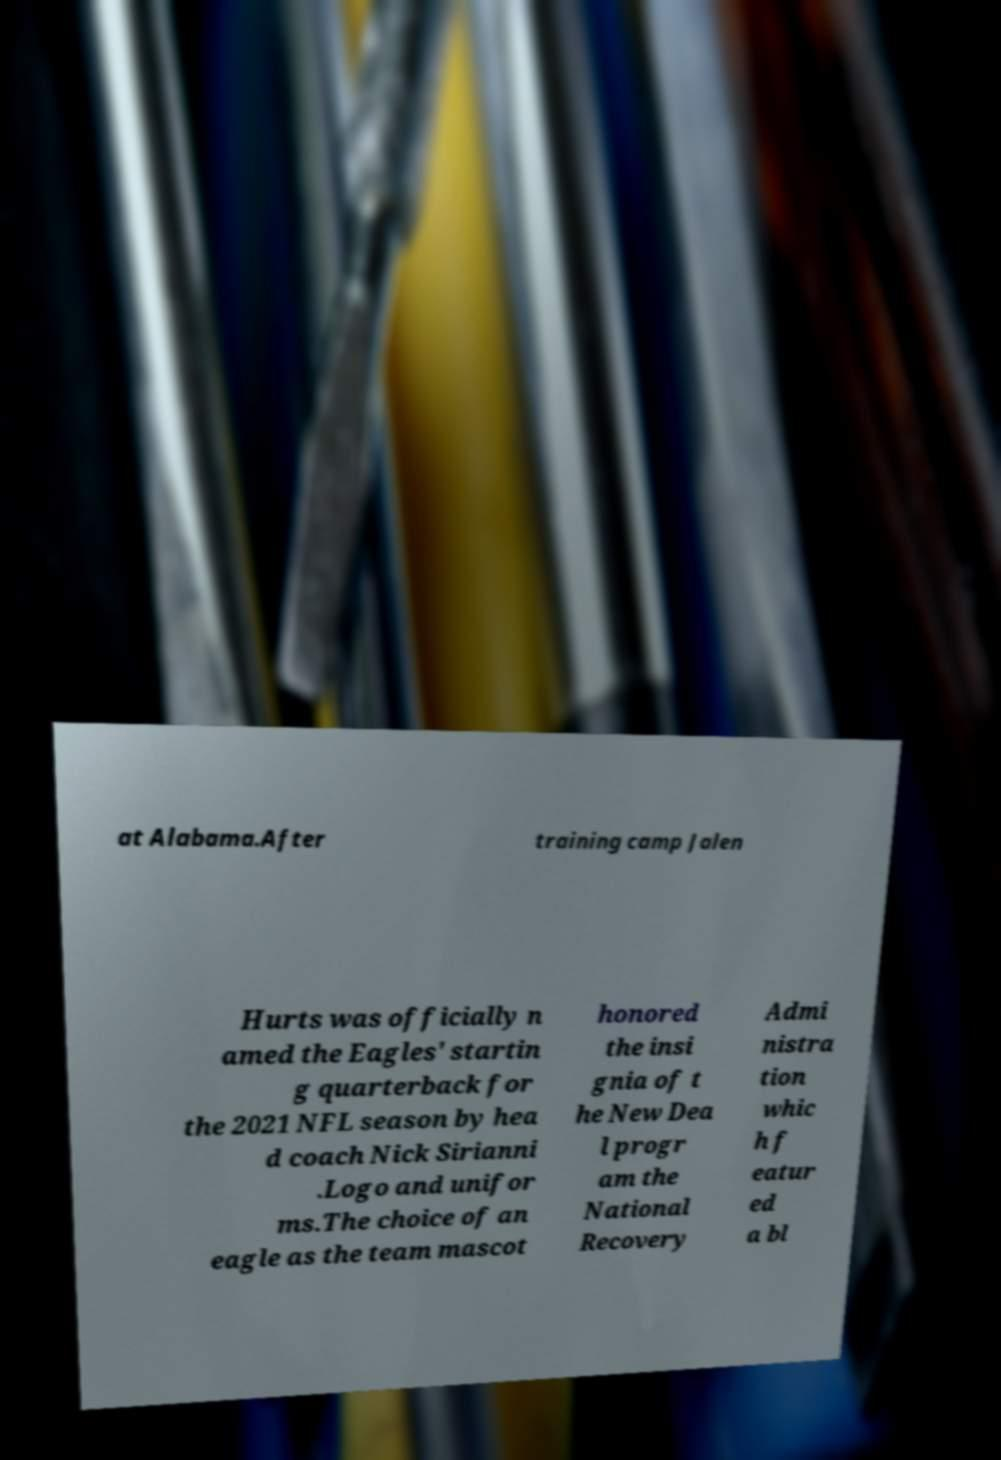What messages or text are displayed in this image? I need them in a readable, typed format. at Alabama.After training camp Jalen Hurts was officially n amed the Eagles' startin g quarterback for the 2021 NFL season by hea d coach Nick Sirianni .Logo and unifor ms.The choice of an eagle as the team mascot honored the insi gnia of t he New Dea l progr am the National Recovery Admi nistra tion whic h f eatur ed a bl 